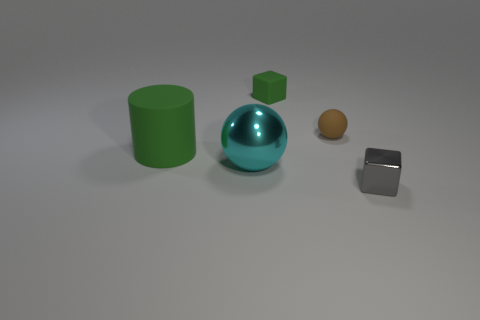There is a tiny rubber cube; does it have the same color as the big rubber cylinder that is on the left side of the tiny gray block?
Provide a succinct answer. Yes. What is the material of the small thing that is the same color as the cylinder?
Provide a succinct answer. Rubber. What is the size of the thing that is the same color as the matte cylinder?
Offer a terse response. Small. Is the size of the green rubber object behind the green matte cylinder the same as the object to the right of the brown matte thing?
Your answer should be very brief. Yes. What is the size of the cube left of the gray cube?
Your response must be concise. Small. Is there a matte ball of the same color as the small matte cube?
Offer a very short reply. No. Are there any cyan objects behind the sphere that is on the left side of the tiny brown sphere?
Your answer should be very brief. No. Does the matte sphere have the same size as the cube in front of the green cylinder?
Provide a short and direct response. Yes. There is a shiny object that is behind the tiny metal thing in front of the rubber sphere; are there any metallic balls behind it?
Your answer should be compact. No. There is a ball that is right of the big cyan shiny object; what material is it?
Offer a very short reply. Rubber. 